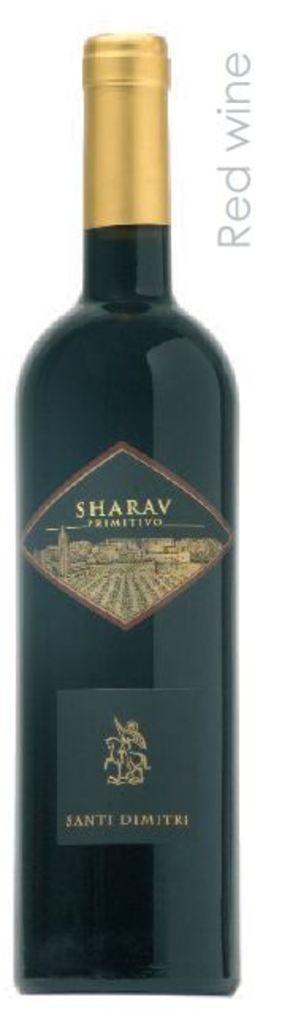<image>
Give a short and clear explanation of the subsequent image. A Red Wine advertisement for a bottle of Sharav Primitivo Santi Dimitri. 